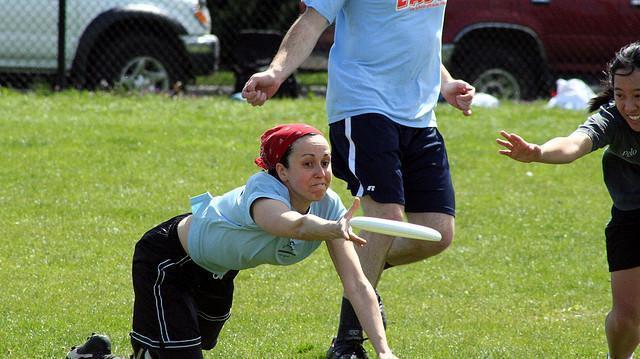What is the woman ready to do?
Indicate the correct response by choosing from the four available options to answer the question.
Options: Catch, roll, run, eat. Catch. 